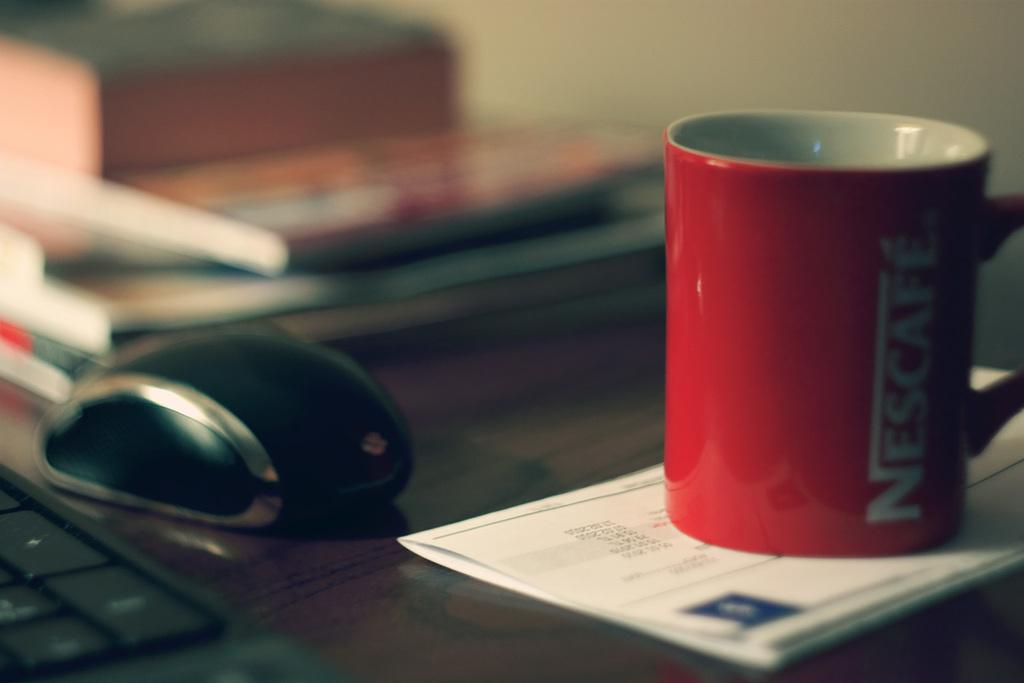Provide a one-sentence caption for the provided image. Red cup of Nescafe next to a computer mouse on a table. 